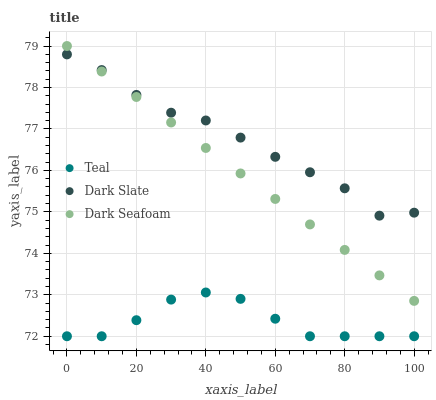Does Teal have the minimum area under the curve?
Answer yes or no. Yes. Does Dark Slate have the maximum area under the curve?
Answer yes or no. Yes. Does Dark Seafoam have the minimum area under the curve?
Answer yes or no. No. Does Dark Seafoam have the maximum area under the curve?
Answer yes or no. No. Is Dark Seafoam the smoothest?
Answer yes or no. Yes. Is Dark Slate the roughest?
Answer yes or no. Yes. Is Teal the smoothest?
Answer yes or no. No. Is Teal the roughest?
Answer yes or no. No. Does Teal have the lowest value?
Answer yes or no. Yes. Does Dark Seafoam have the lowest value?
Answer yes or no. No. Does Dark Seafoam have the highest value?
Answer yes or no. Yes. Does Teal have the highest value?
Answer yes or no. No. Is Teal less than Dark Slate?
Answer yes or no. Yes. Is Dark Seafoam greater than Teal?
Answer yes or no. Yes. Does Dark Slate intersect Dark Seafoam?
Answer yes or no. Yes. Is Dark Slate less than Dark Seafoam?
Answer yes or no. No. Is Dark Slate greater than Dark Seafoam?
Answer yes or no. No. Does Teal intersect Dark Slate?
Answer yes or no. No. 